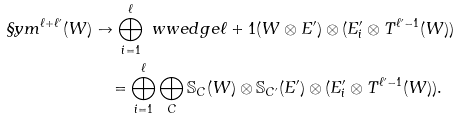Convert formula to latex. <formula><loc_0><loc_0><loc_500><loc_500>\S y m ^ { \ell + \ell ^ { \prime } } ( W ) & \to \bigoplus _ { i = 1 } ^ { \ell } \ w w e d g e { \ell + 1 } ( W \otimes E ^ { \prime } ) \otimes ( E ^ { \prime } _ { i } \otimes T ^ { \ell ^ { \prime } - 1 } ( W ) ) \\ & \quad = \bigoplus _ { i = 1 } ^ { \ell } \bigoplus _ { C } \mathbb { S } _ { C } ( W ) \otimes \mathbb { S } _ { C ^ { \prime } } ( E ^ { \prime } ) \otimes ( E ^ { \prime } _ { i } \otimes T ^ { \ell ^ { \prime } - 1 } ( W ) ) .</formula> 